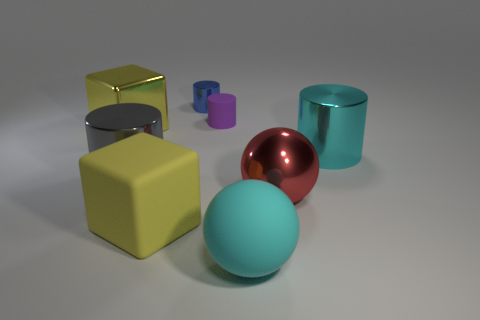Add 2 tiny brown blocks. How many objects exist? 10 Subtract all balls. How many objects are left? 6 Subtract 0 green cylinders. How many objects are left? 8 Subtract all big cyan cylinders. Subtract all big red metal spheres. How many objects are left? 6 Add 2 gray metal things. How many gray metal things are left? 3 Add 6 small purple rubber things. How many small purple rubber things exist? 7 